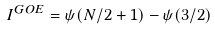Convert formula to latex. <formula><loc_0><loc_0><loc_500><loc_500>I ^ { G O E } = \psi ( N / 2 + 1 ) - \psi ( 3 / 2 )</formula> 